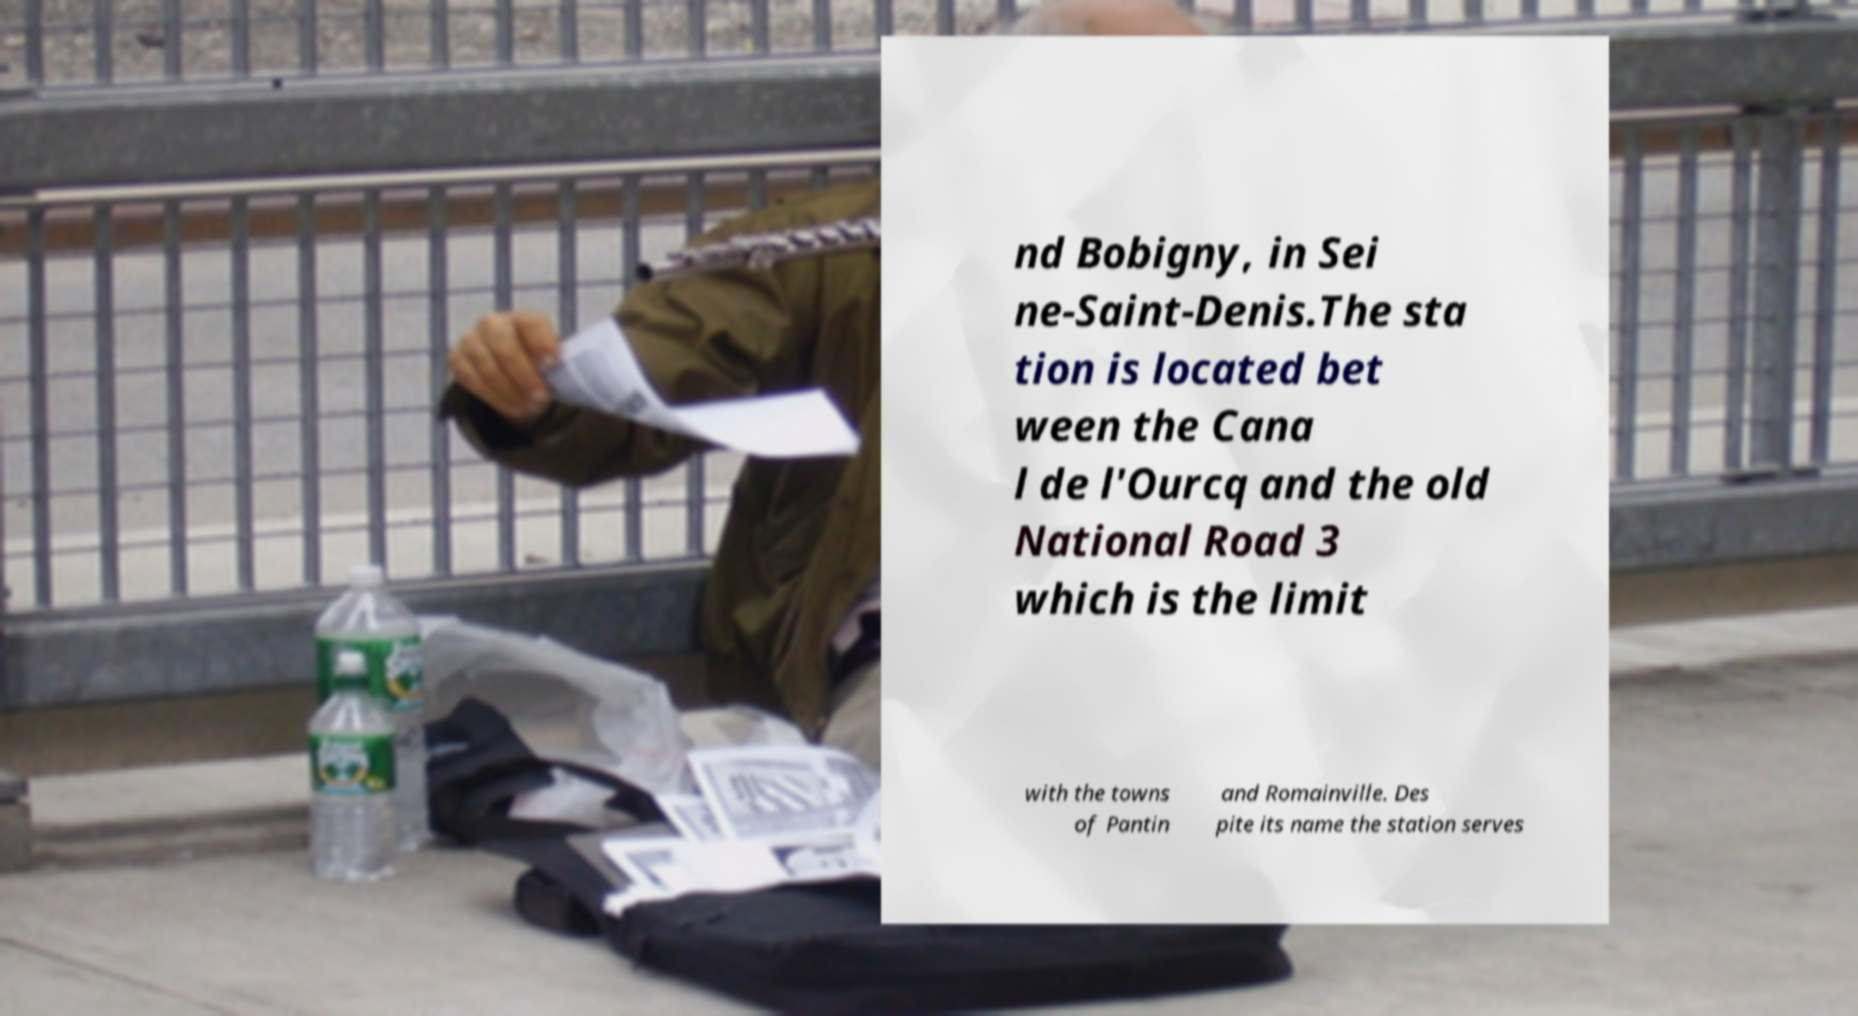For documentation purposes, I need the text within this image transcribed. Could you provide that? nd Bobigny, in Sei ne-Saint-Denis.The sta tion is located bet ween the Cana l de l'Ourcq and the old National Road 3 which is the limit with the towns of Pantin and Romainville. Des pite its name the station serves 